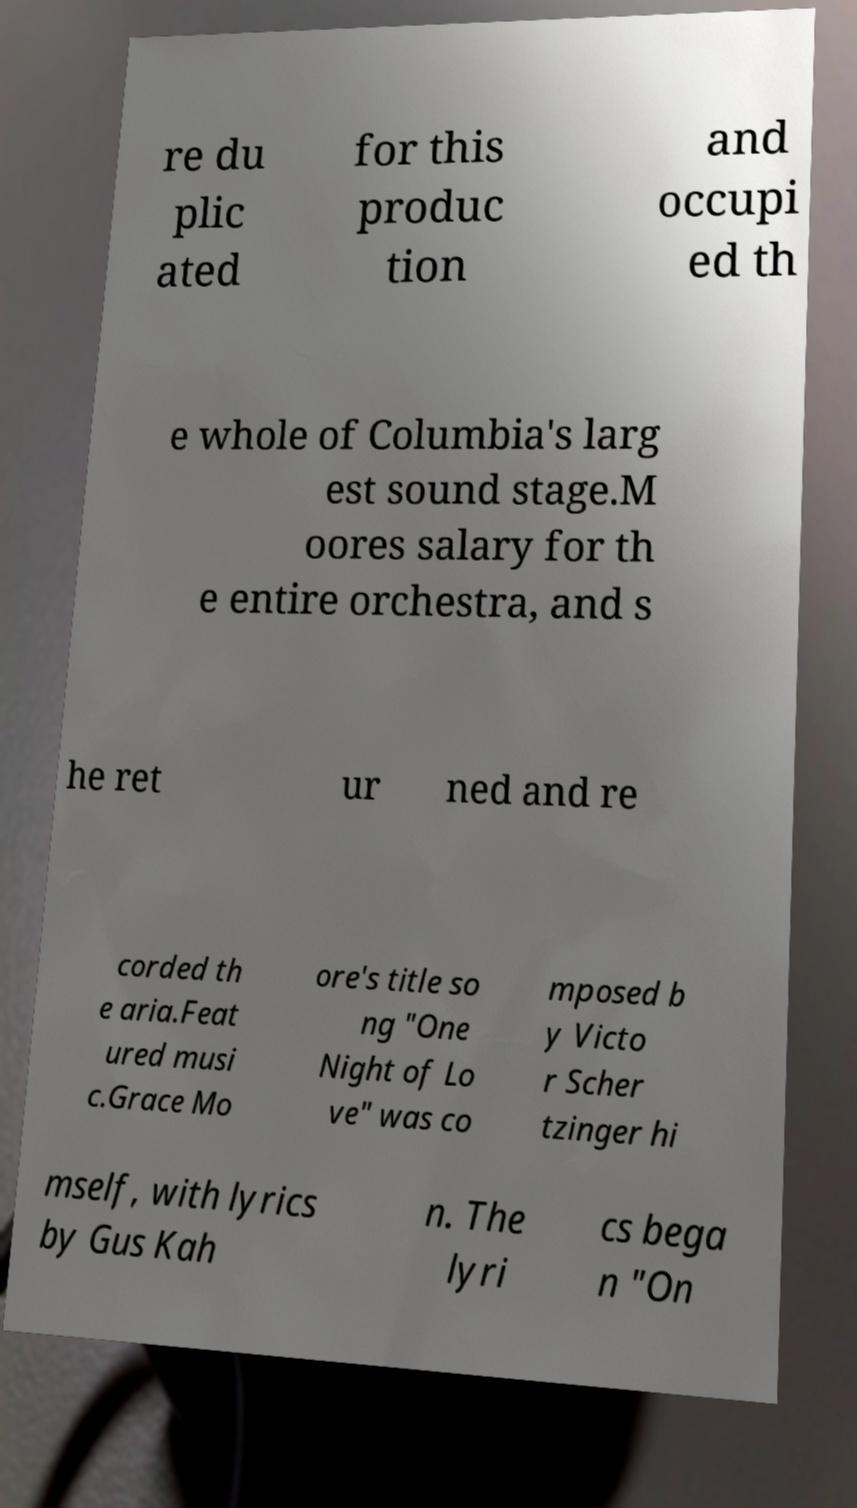I need the written content from this picture converted into text. Can you do that? re du plic ated for this produc tion and occupi ed th e whole of Columbia's larg est sound stage.M oores salary for th e entire orchestra, and s he ret ur ned and re corded th e aria.Feat ured musi c.Grace Mo ore's title so ng "One Night of Lo ve" was co mposed b y Victo r Scher tzinger hi mself, with lyrics by Gus Kah n. The lyri cs bega n "On 